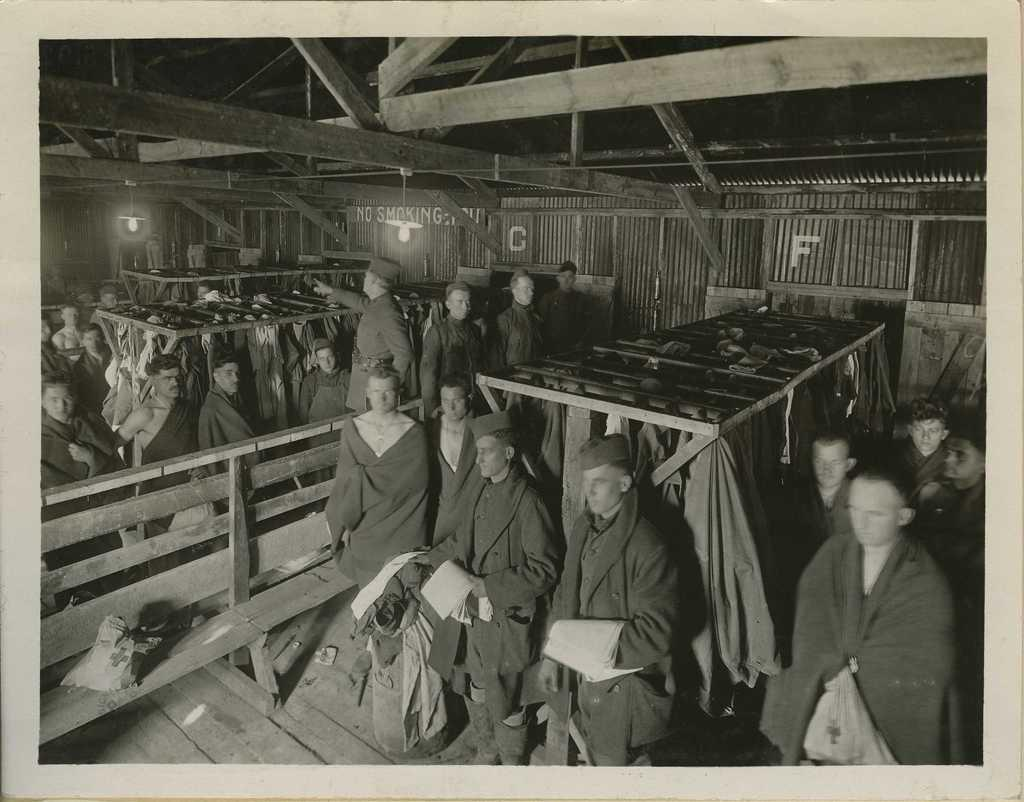What is the color scheme of the image? The image is black and white. What can be seen in the image in terms of people? There is a group of people standing in the image. What type of fencing is present in the image? There is a wooden fence in the image. What is written or displayed on the wall in the image? There is a wall with text in the image. What type of lighting is visible in the image? There are ceiling lights in the image. What part of a building can be seen in the image? There is a roof visible in the image. How many birds are perched on the horn in the image? There is no horn or birds present in the image. 